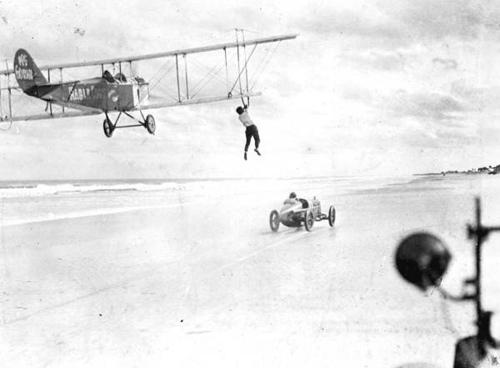Is this a modern photo?
Be succinct. No. Is that a modern car?
Answer briefly. No. What is hanging onto the plane?
Answer briefly. Man. How many vehicles are in this picture?
Write a very short answer. 2. 